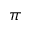<formula> <loc_0><loc_0><loc_500><loc_500>\pi</formula> 